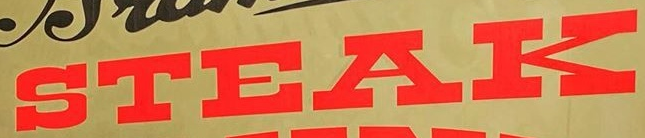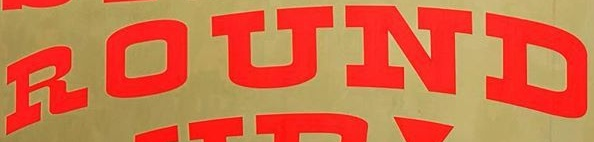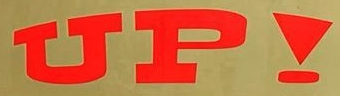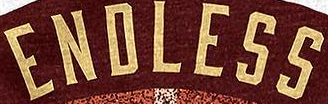Read the text from these images in sequence, separated by a semicolon. STEAK; ROUND; UP!; ENDLESS 